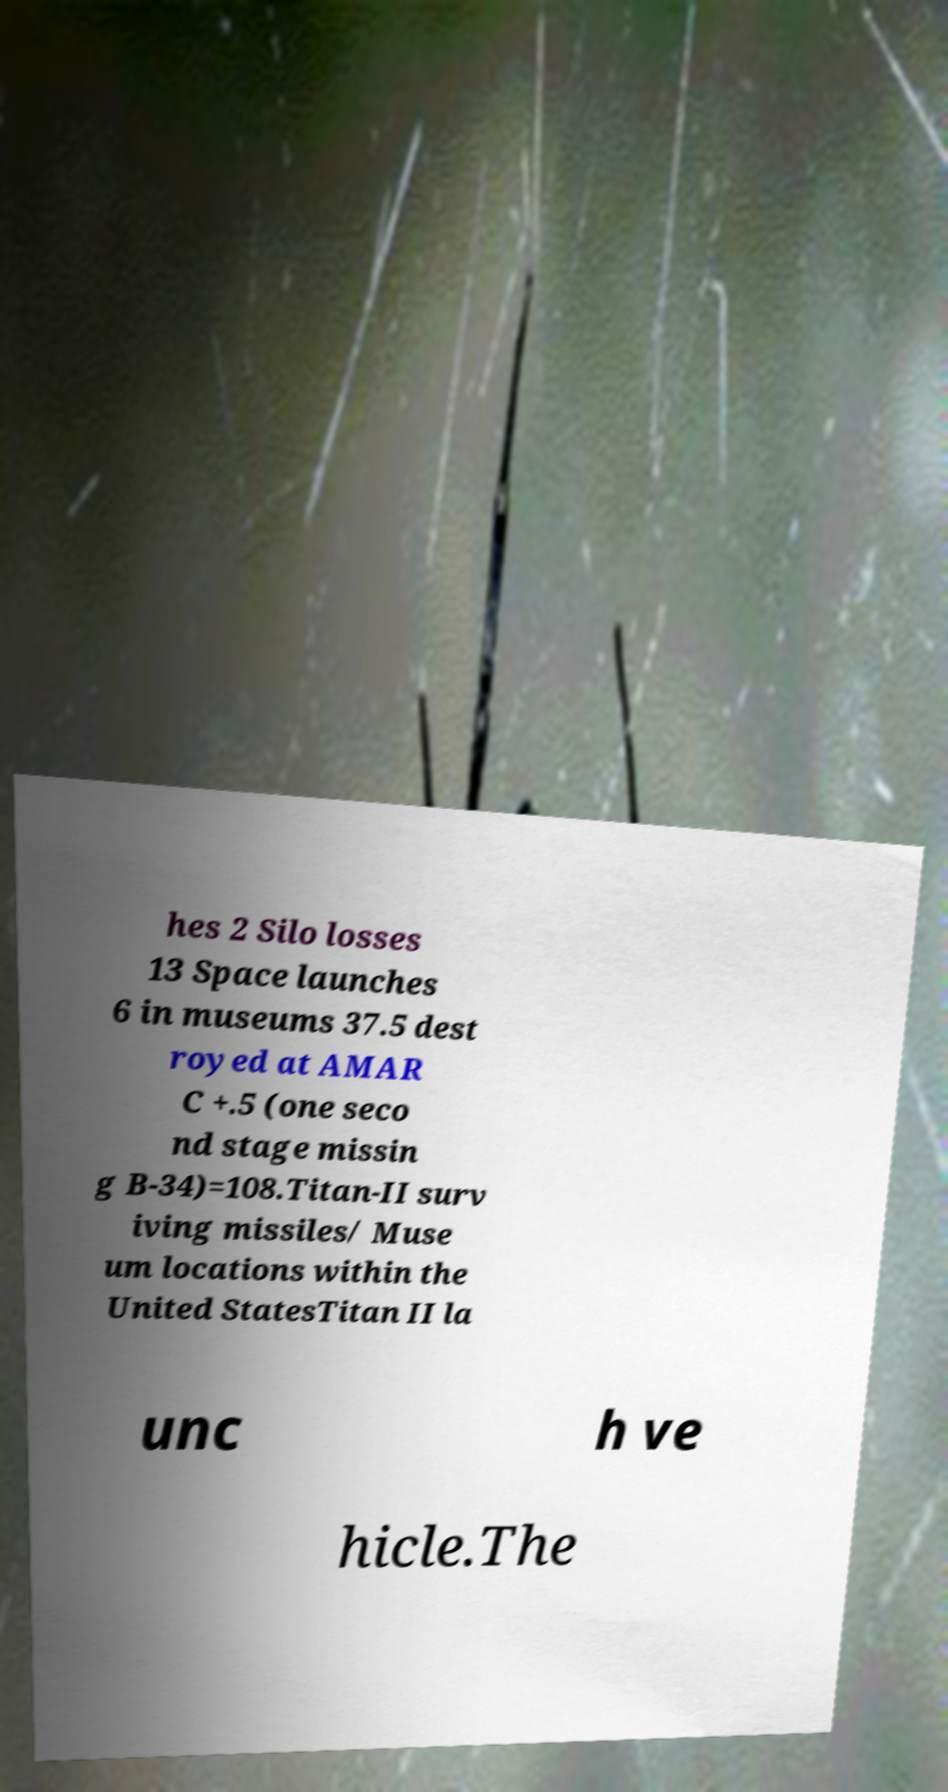Please read and relay the text visible in this image. What does it say? hes 2 Silo losses 13 Space launches 6 in museums 37.5 dest royed at AMAR C +.5 (one seco nd stage missin g B-34)=108.Titan-II surv iving missiles/ Muse um locations within the United StatesTitan II la unc h ve hicle.The 